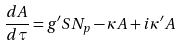Convert formula to latex. <formula><loc_0><loc_0><loc_500><loc_500>\frac { d A } { d \tau } = g ^ { \prime } S N _ { p } - \kappa A + i \kappa ^ { \prime } A</formula> 